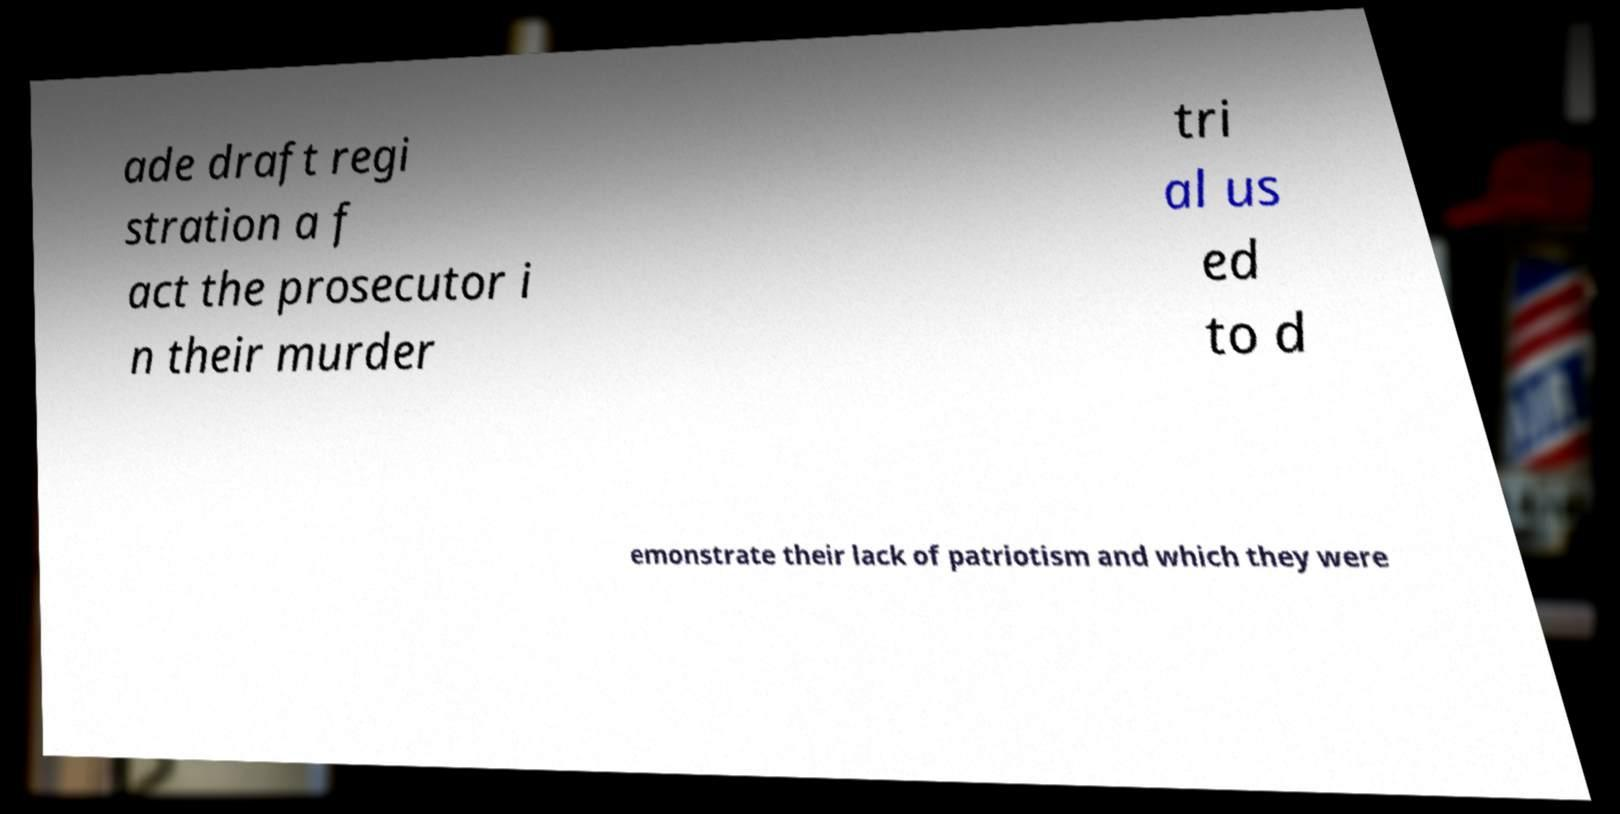Could you assist in decoding the text presented in this image and type it out clearly? ade draft regi stration a f act the prosecutor i n their murder tri al us ed to d emonstrate their lack of patriotism and which they were 